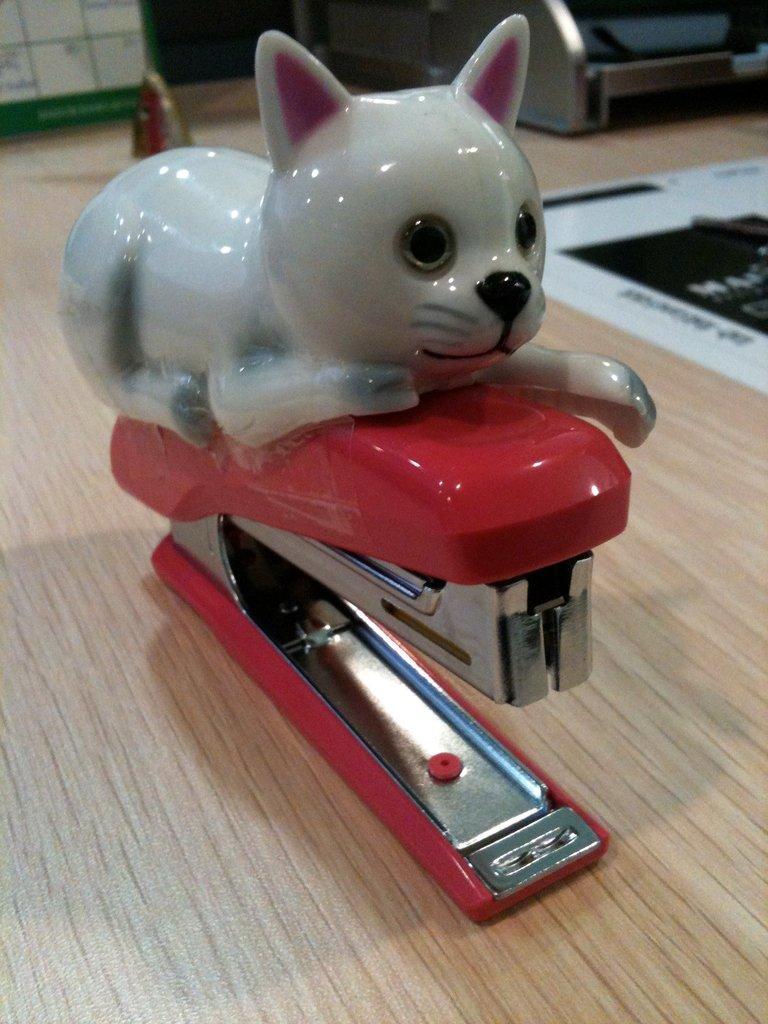Could you give a brief overview of what you see in this image? In this picture we can see the red stapler with small cat toy on the top is placed on the wooden table. 